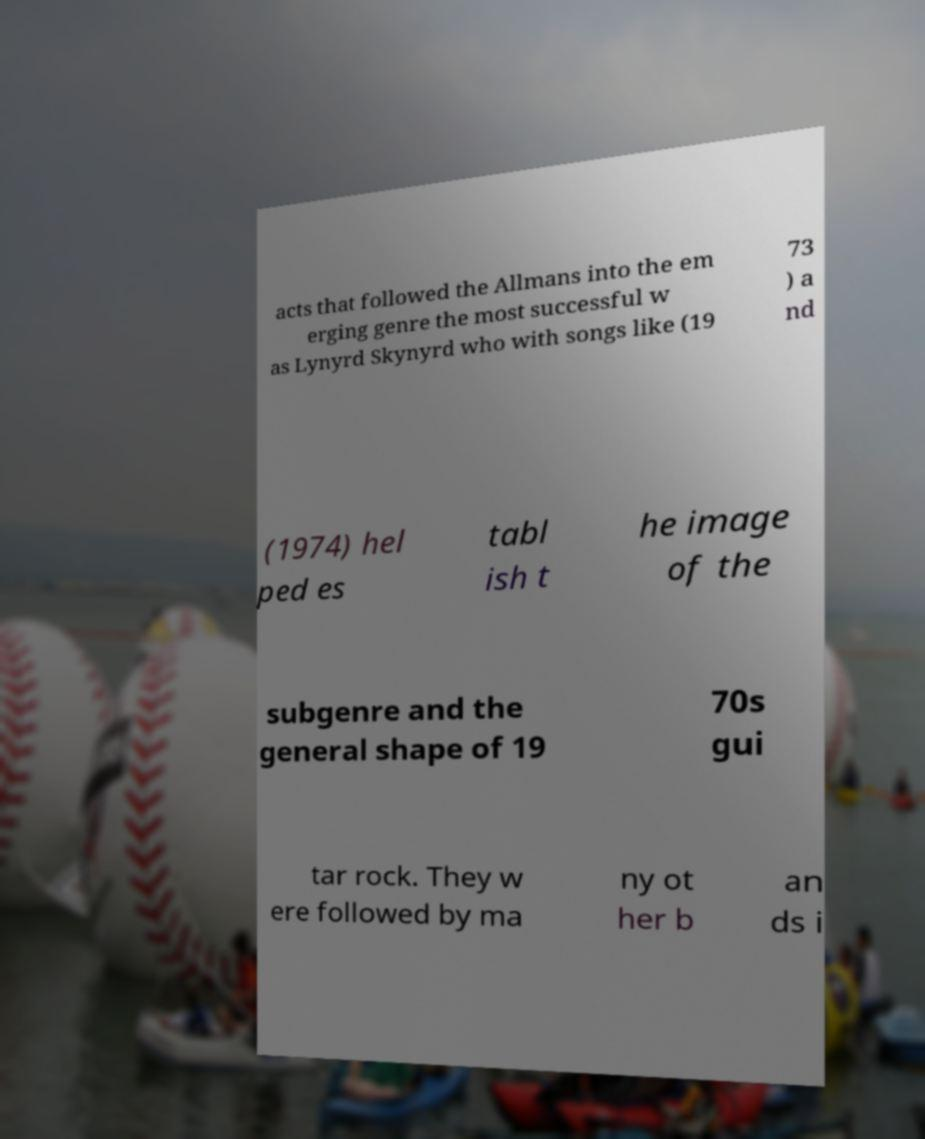There's text embedded in this image that I need extracted. Can you transcribe it verbatim? acts that followed the Allmans into the em erging genre the most successful w as Lynyrd Skynyrd who with songs like (19 73 ) a nd (1974) hel ped es tabl ish t he image of the subgenre and the general shape of 19 70s gui tar rock. They w ere followed by ma ny ot her b an ds i 